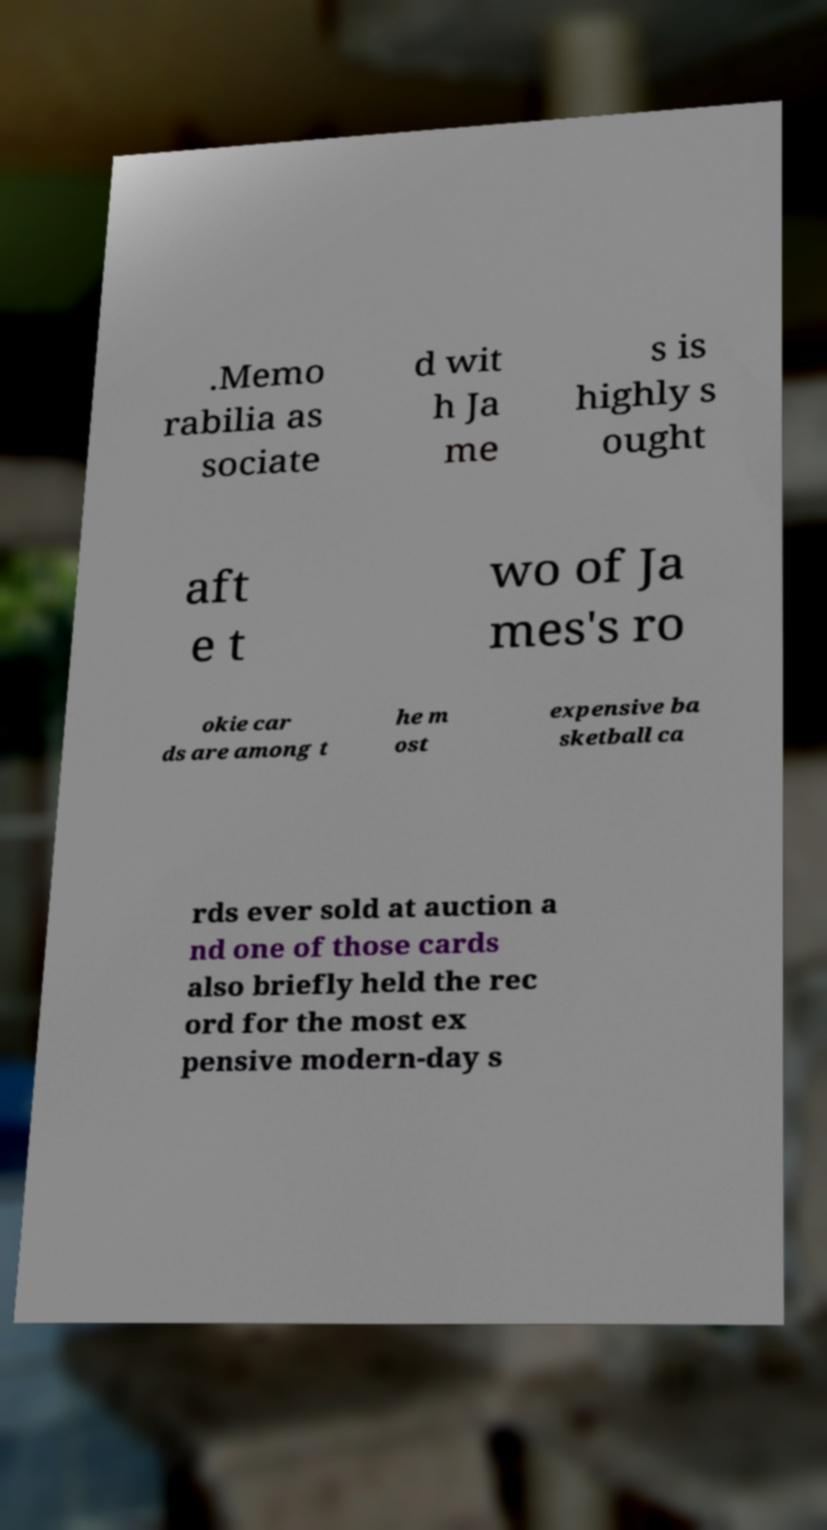I need the written content from this picture converted into text. Can you do that? .Memo rabilia as sociate d wit h Ja me s is highly s ought aft e t wo of Ja mes's ro okie car ds are among t he m ost expensive ba sketball ca rds ever sold at auction a nd one of those cards also briefly held the rec ord for the most ex pensive modern-day s 